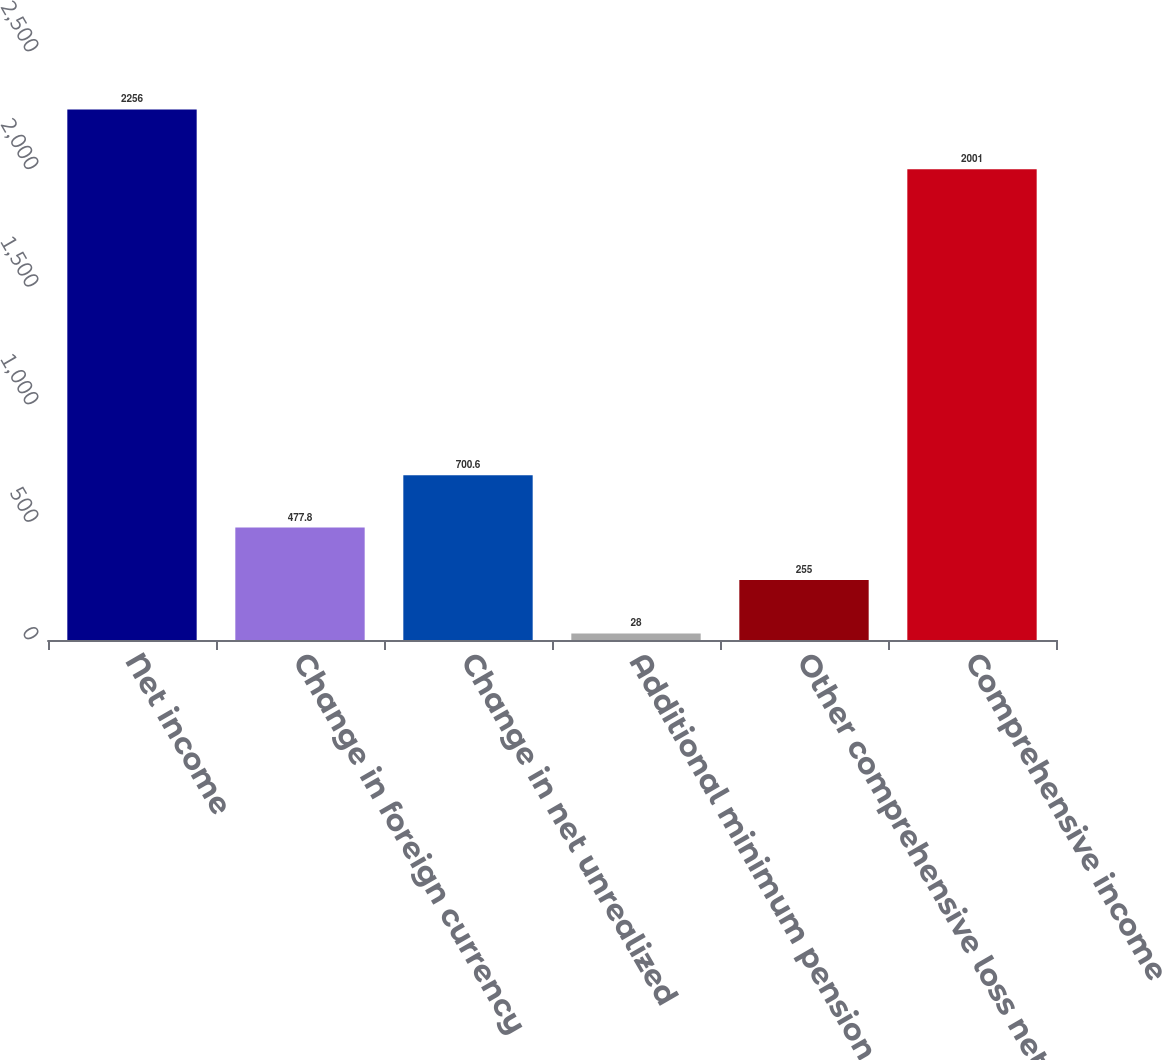<chart> <loc_0><loc_0><loc_500><loc_500><bar_chart><fcel>Net income<fcel>Change in foreign currency<fcel>Change in net unrealized<fcel>Additional minimum pension<fcel>Other comprehensive loss net<fcel>Comprehensive income<nl><fcel>2256<fcel>477.8<fcel>700.6<fcel>28<fcel>255<fcel>2001<nl></chart> 